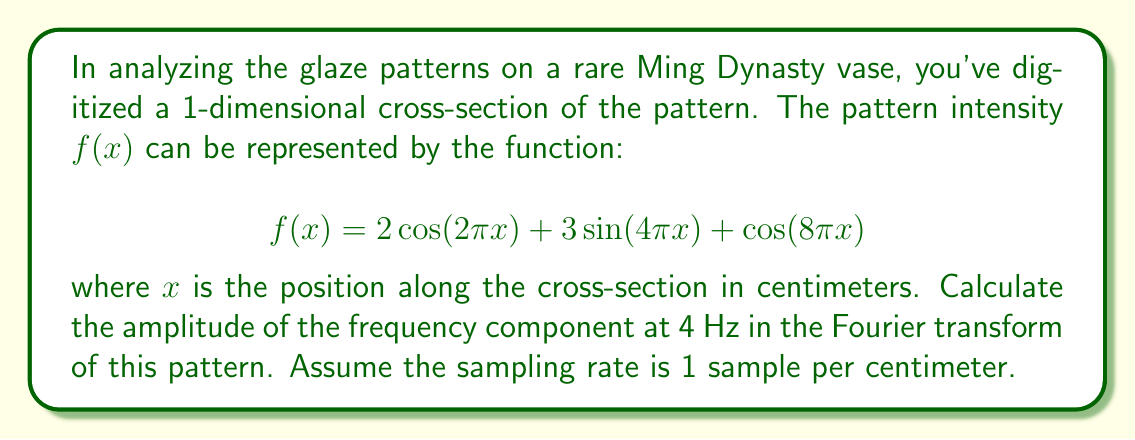Could you help me with this problem? To solve this problem, we need to follow these steps:

1) First, recall that the Fourier transform of a cosine or sine function with frequency $\omega$ is given by:

   $$\mathcal{F}\{\cos(\omega x)\} = \pi[\delta(\omega + \omega_0) + \delta(\omega - \omega_0)]$$
   $$\mathcal{F}\{\sin(\omega x)\} = -i\pi[\delta(\omega + \omega_0) - \delta(\omega - \omega_0)]$$

   where $\delta$ is the Dirac delta function.

2) Our function $f(x)$ consists of three components:
   
   a) $2\cos(2\pi x)$: frequency is 1 Hz
   b) $3\sin(4\pi x)$: frequency is 2 Hz
   c) $\cos(8\pi x)$: frequency is 4 Hz

3) We're interested in the component at 4 Hz, which is $\cos(8\pi x)$.

4) The Fourier transform of this component is:

   $$\mathcal{F}\{\cos(8\pi x)\} = \pi[\delta(\omega + 8\pi) + \delta(\omega - 8\pi)]$$

5) The amplitude of this component in the frequency domain is given by the coefficient of the cosine term, which is 1.

Therefore, the amplitude of the frequency component at 4 Hz in the Fourier transform of this pattern is 1.
Answer: 1 